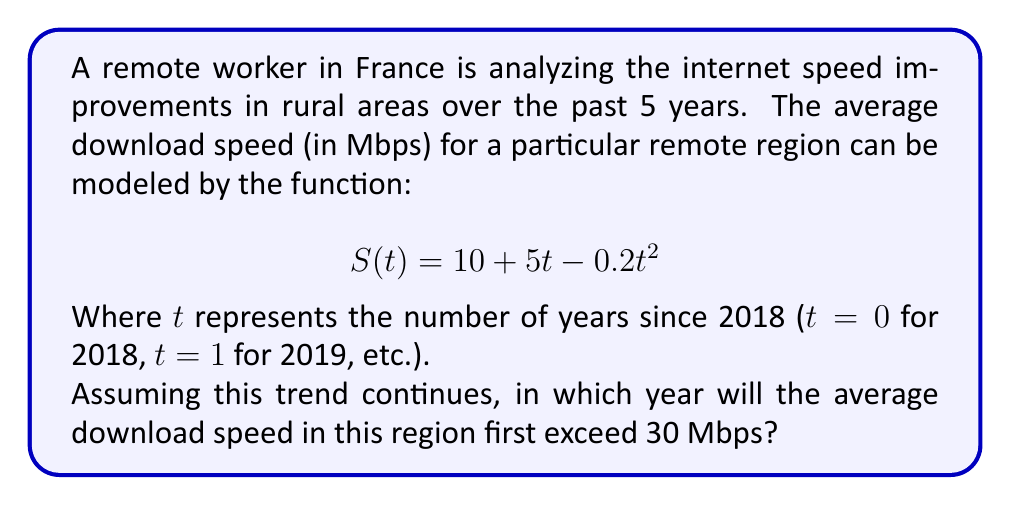Help me with this question. To solve this problem, we need to find the value of $t$ where $S(t)$ first exceeds 30 Mbps. Let's approach this step-by-step:

1) We start with the equation:
   $$S(t) = 10 + 5t - 0.2t^2$$

2) We want to find when this becomes greater than 30:
   $$10 + 5t - 0.2t^2 > 30$$

3) Rearranging the inequality:
   $$-0.2t^2 + 5t - 20 > 0$$

4) This is a quadratic inequality. To solve it, we first find the roots of the corresponding quadratic equation:
   $$-0.2t^2 + 5t - 20 = 0$$

5) Using the quadratic formula $\frac{-b \pm \sqrt{b^2 - 4ac}}{2a}$:
   $$t = \frac{-5 \pm \sqrt{5^2 - 4(-0.2)(-20)}}{2(-0.2)}$$
   $$t = \frac{-5 \pm \sqrt{25 - 16}}{-0.4}$$
   $$t = \frac{-5 \pm 3}{-0.4}$$

6) This gives us two solutions:
   $$t_1 = \frac{-5 + 3}{-0.4} = 5$$
   $$t_2 = \frac{-5 - 3}{-0.4} = 20$$

7) The inequality is satisfied when $t$ is between these two values: $5 < t < 20$

8) Since we're looking for the first time it exceeds 30 Mbps, we're interested in the lower bound.

9) $t = 5$ corresponds to 5 years after 2018, which is 2023.

10) However, we need the first year it exceeds 30 Mbps, so we round up to the next integer year: 2024.
Answer: 2024 